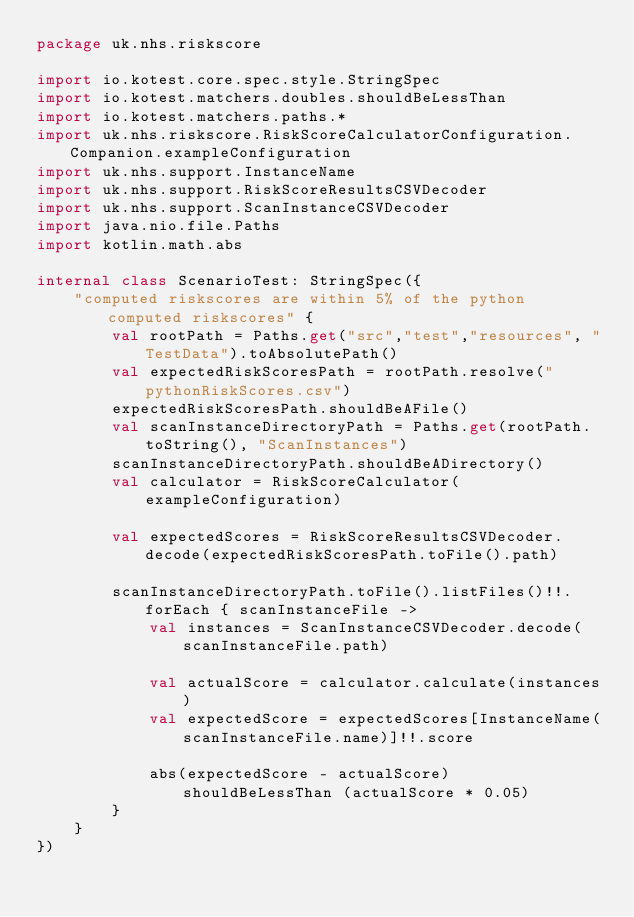Convert code to text. <code><loc_0><loc_0><loc_500><loc_500><_Kotlin_>package uk.nhs.riskscore

import io.kotest.core.spec.style.StringSpec
import io.kotest.matchers.doubles.shouldBeLessThan
import io.kotest.matchers.paths.*
import uk.nhs.riskscore.RiskScoreCalculatorConfiguration.Companion.exampleConfiguration
import uk.nhs.support.InstanceName
import uk.nhs.support.RiskScoreResultsCSVDecoder
import uk.nhs.support.ScanInstanceCSVDecoder
import java.nio.file.Paths
import kotlin.math.abs

internal class ScenarioTest: StringSpec({
    "computed riskscores are within 5% of the python computed riskscores" {
        val rootPath = Paths.get("src","test","resources", "TestData").toAbsolutePath()
        val expectedRiskScoresPath = rootPath.resolve("pythonRiskScores.csv")
        expectedRiskScoresPath.shouldBeAFile()
        val scanInstanceDirectoryPath = Paths.get(rootPath.toString(), "ScanInstances")
        scanInstanceDirectoryPath.shouldBeADirectory()
        val calculator = RiskScoreCalculator(exampleConfiguration)

        val expectedScores = RiskScoreResultsCSVDecoder.decode(expectedRiskScoresPath.toFile().path)

        scanInstanceDirectoryPath.toFile().listFiles()!!.forEach { scanInstanceFile ->
            val instances = ScanInstanceCSVDecoder.decode(scanInstanceFile.path)

            val actualScore = calculator.calculate(instances)
            val expectedScore = expectedScores[InstanceName(scanInstanceFile.name)]!!.score

            abs(expectedScore - actualScore) shouldBeLessThan (actualScore * 0.05)
        }
    }
})</code> 